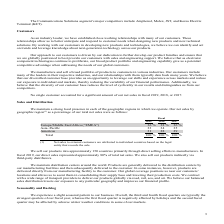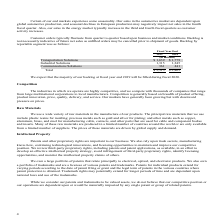According to Te Connectivity's financial document, What are sales in the automotive market dependent upon? dependent upon global automotive production, and seasonal declines in European production may negatively impact net sales in the fourth fiscal quarter. The document states: "asonality. Our sales in the automotive market are dependent upon global automotive production, and seasonal declines in European production may negati..." Also, When do sales in the energy market typically increase? in the third and fourth fiscal quarters as customer activity increases. The document states: "our sales in the energy market typically increase in the third and fourth fiscal quarters as customer activity increases...." Also, What were the segments for which backlog was calculated in the table? The document contains multiple relevant values: Transportation Solutions, Industrial Solutions, Communications Solutions. From the document: "Transportation Solutions $ 1,639 $ 1,779 Industrial Solutions 1,315 1,245 Communications Solutions 361 441..." Additionally, In which year was Communications Solutions larger? According to the financial document, 2018. The relevant text states: "2019 2018 2017..." Also, can you calculate: What was the change in total backlog in 2019 from 2018? Based on the calculation: 3,315-3,465, the result is -150 (in millions). This is based on the information: "Total $ 3,315 $ 3,465 Total $ 3,315 $ 3,465..." The key data points involved are: 3,315, 3,465. Also, can you calculate: What was the percentage change in total backlog in 2019 from 2018? To answer this question, I need to perform calculations using the financial data. The calculation is: (3,315-3,465)/3,465, which equals -4.33 (percentage). This is based on the information: "Total $ 3,315 $ 3,465 Total $ 3,315 $ 3,465..." The key data points involved are: 3,315, 3,465. 